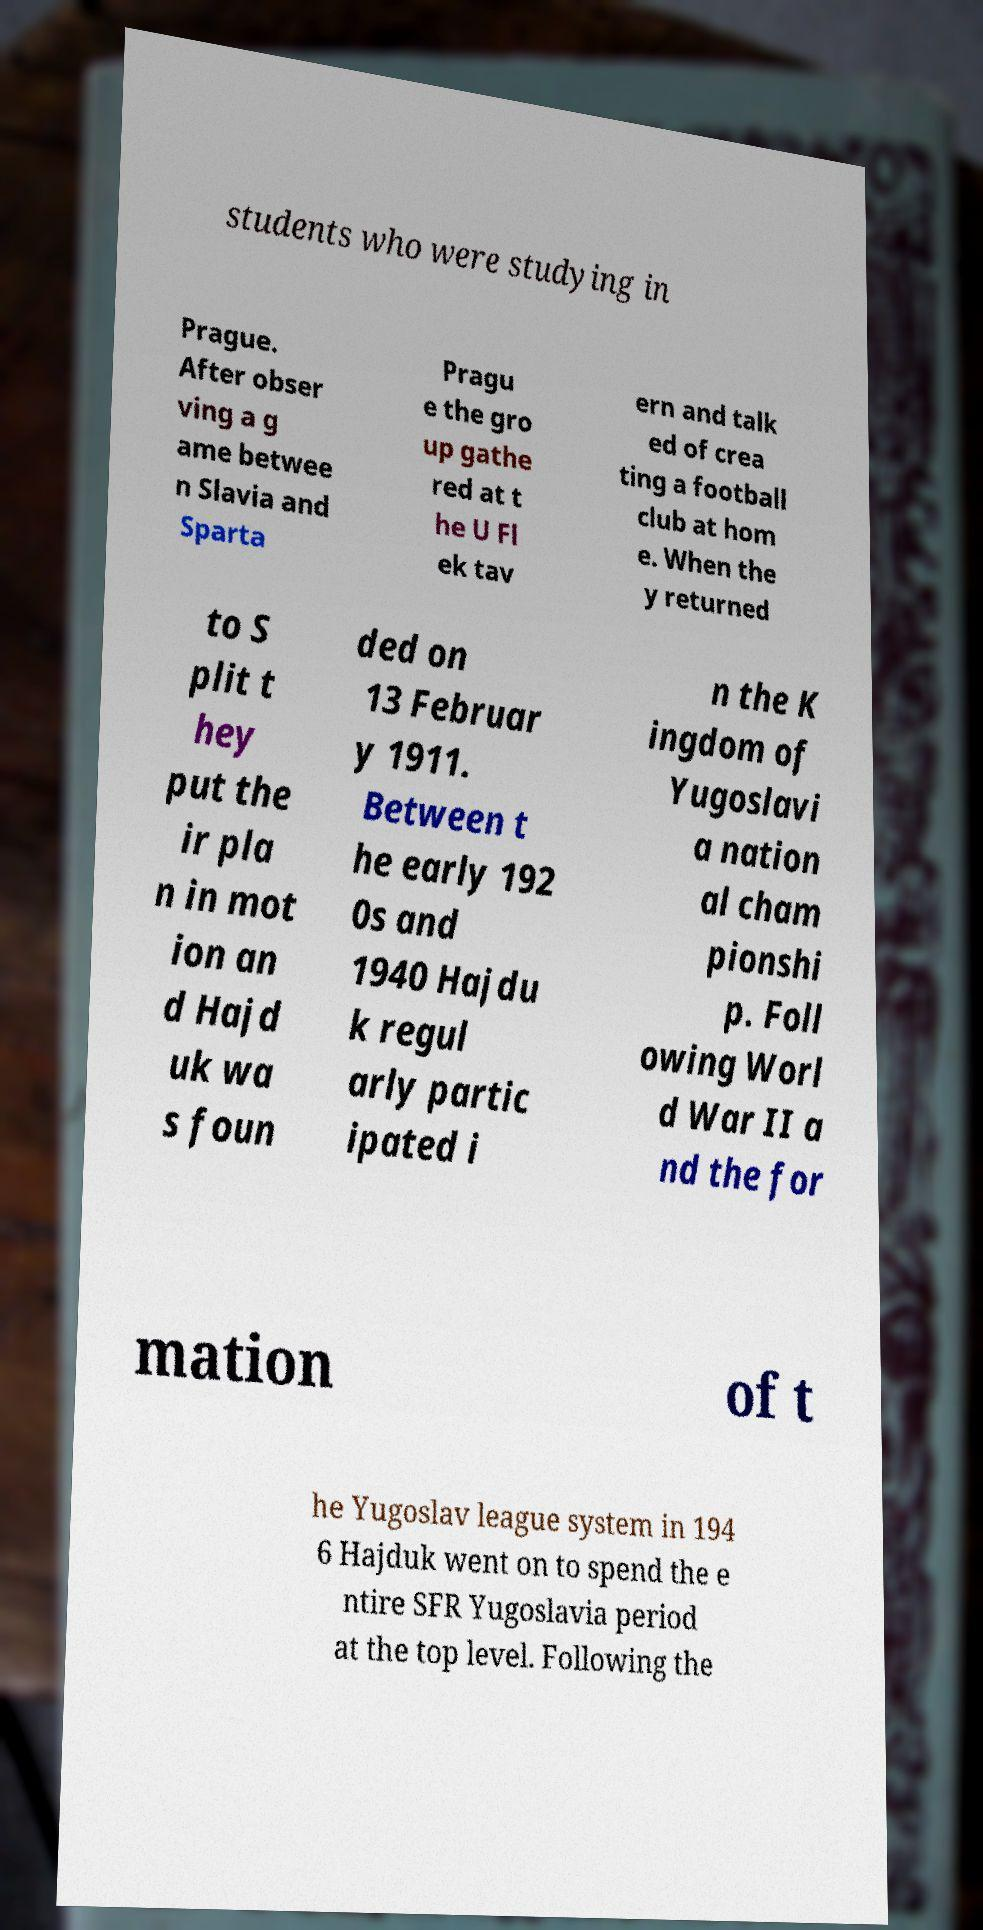Can you read and provide the text displayed in the image?This photo seems to have some interesting text. Can you extract and type it out for me? students who were studying in Prague. After obser ving a g ame betwee n Slavia and Sparta Pragu e the gro up gathe red at t he U Fl ek tav ern and talk ed of crea ting a football club at hom e. When the y returned to S plit t hey put the ir pla n in mot ion an d Hajd uk wa s foun ded on 13 Februar y 1911. Between t he early 192 0s and 1940 Hajdu k regul arly partic ipated i n the K ingdom of Yugoslavi a nation al cham pionshi p. Foll owing Worl d War II a nd the for mation of t he Yugoslav league system in 194 6 Hajduk went on to spend the e ntire SFR Yugoslavia period at the top level. Following the 